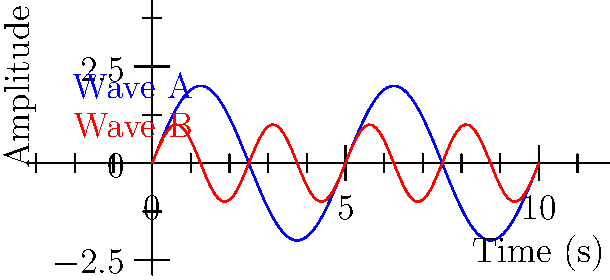In a factory setting, two sound waves from different pieces of equipment are detected, as shown in the graph. Wave A (blue) has a frequency of 0.2 Hz, while Wave B (red) has a frequency of 0.4 Hz. If these waves were to interfere, what would be the beat frequency observed by workers on the factory floor? To solve this problem, we need to follow these steps:

1. Recall the formula for beat frequency:
   Beat frequency = $|f_1 - f_2|$, where $f_1$ and $f_2$ are the frequencies of the two interfering waves.

2. Identify the frequencies of the two waves:
   Wave A (blue): $f_1 = 0.2$ Hz
   Wave B (red): $f_2 = 0.4$ Hz

3. Apply the beat frequency formula:
   Beat frequency = $|f_1 - f_2|$ = $|0.2 \text{ Hz} - 0.4 \text{ Hz}|$ = $|{-0.2 \text{ Hz}}|$ = $0.2$ Hz

The beat frequency is the absolute value of the difference between the two wave frequencies, which is 0.2 Hz in this case.
Answer: 0.2 Hz 